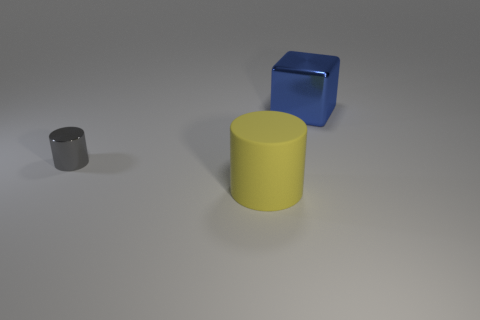There is a thing behind the cylinder that is on the left side of the large yellow rubber cylinder; is there a large rubber object to the left of it? Yes, there is an object to the left of the large yellow cylinder – a blue cube-shaped rubber object. 